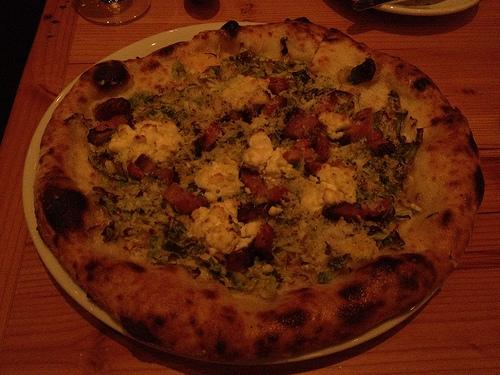Describe the image as if you were introducing it as a meal in a cooking show. Today, we have a delicious personal pizza with blistered crust, mouthwatering toppings like chicken, veggies, and melted cheese. It is beautifully presented on a white plate and set on a charming wood table, ready to be savored! Enjoy! Please provide a detailed analysis of the pizza toppings visible in the image. The pizza appears to have sliced chicken with crusty edges, green vegetable toppings, and possibly some oregano mixed with a white sauce. A white pile of cheese can also be seen, along with a burn bubble on the crust. Briefly describe the image as a social media post. Check out this yummy personal pizza with veggies, cheese, and even some bubbles on the crust! It's all about that cozy, rustic wooden table setting. 🍕🥦🧀 Write a poetic description of the image and the emotions it conveys. A feast for the senses, a moment to remember. Narrate the image as if you were a food critic experiencing it at a restaurant. An inviting personal pizza greets me, displaying a blistered crust with perfectly burned tips. A variety of toppings are generously spread, accompanied by melted cheese, all resting on a round white plate atop a wooden table. Summarize the key features of the image, focusing on the subject and the setting. A cooked individual pizza with burned edges, blisters, and various toppings sits on a round white ceramic plate resting on a wooden table. Provide a description of the pizza in the image as if you are explaining it to someone who cannot see it. There is a personal-sized, vegetable pizza with blistered crust on a white plate placed on a light brown wooden table. The pizza has burned tips and a thick crust with a burn bubble and melted cheese on top. Write a brief assessment of the image's overall aesthetic and visual appeal. The image creates a warm, rustic atmosphere with the wooden table and a round white plate enhancing the visual appeal of the personal pizza. The blistered crust and choice of toppings add to the pizza's enticing appearance. How would you explain the appearance of the table and plate in the image to a friend? The pizza is served on a simple white plate that almost blends in with the wooden table's light brown hue. The plate's shadow can be seen on the wood, accentuating the knot in the tabletop. Imagine you are a chef and describe the pizza presented in this image. The pizza showcases a variety of toppings such as vegetables, chicken, and melted cheese. The crust is thick and has been baked to perfection, displaying a blistered texture and slightly charred edges for a rustic touch. 